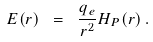Convert formula to latex. <formula><loc_0><loc_0><loc_500><loc_500>E ( r ) \ = \ \frac { q _ { e } } { r ^ { 2 } } H _ { P } ( r ) \, .</formula> 